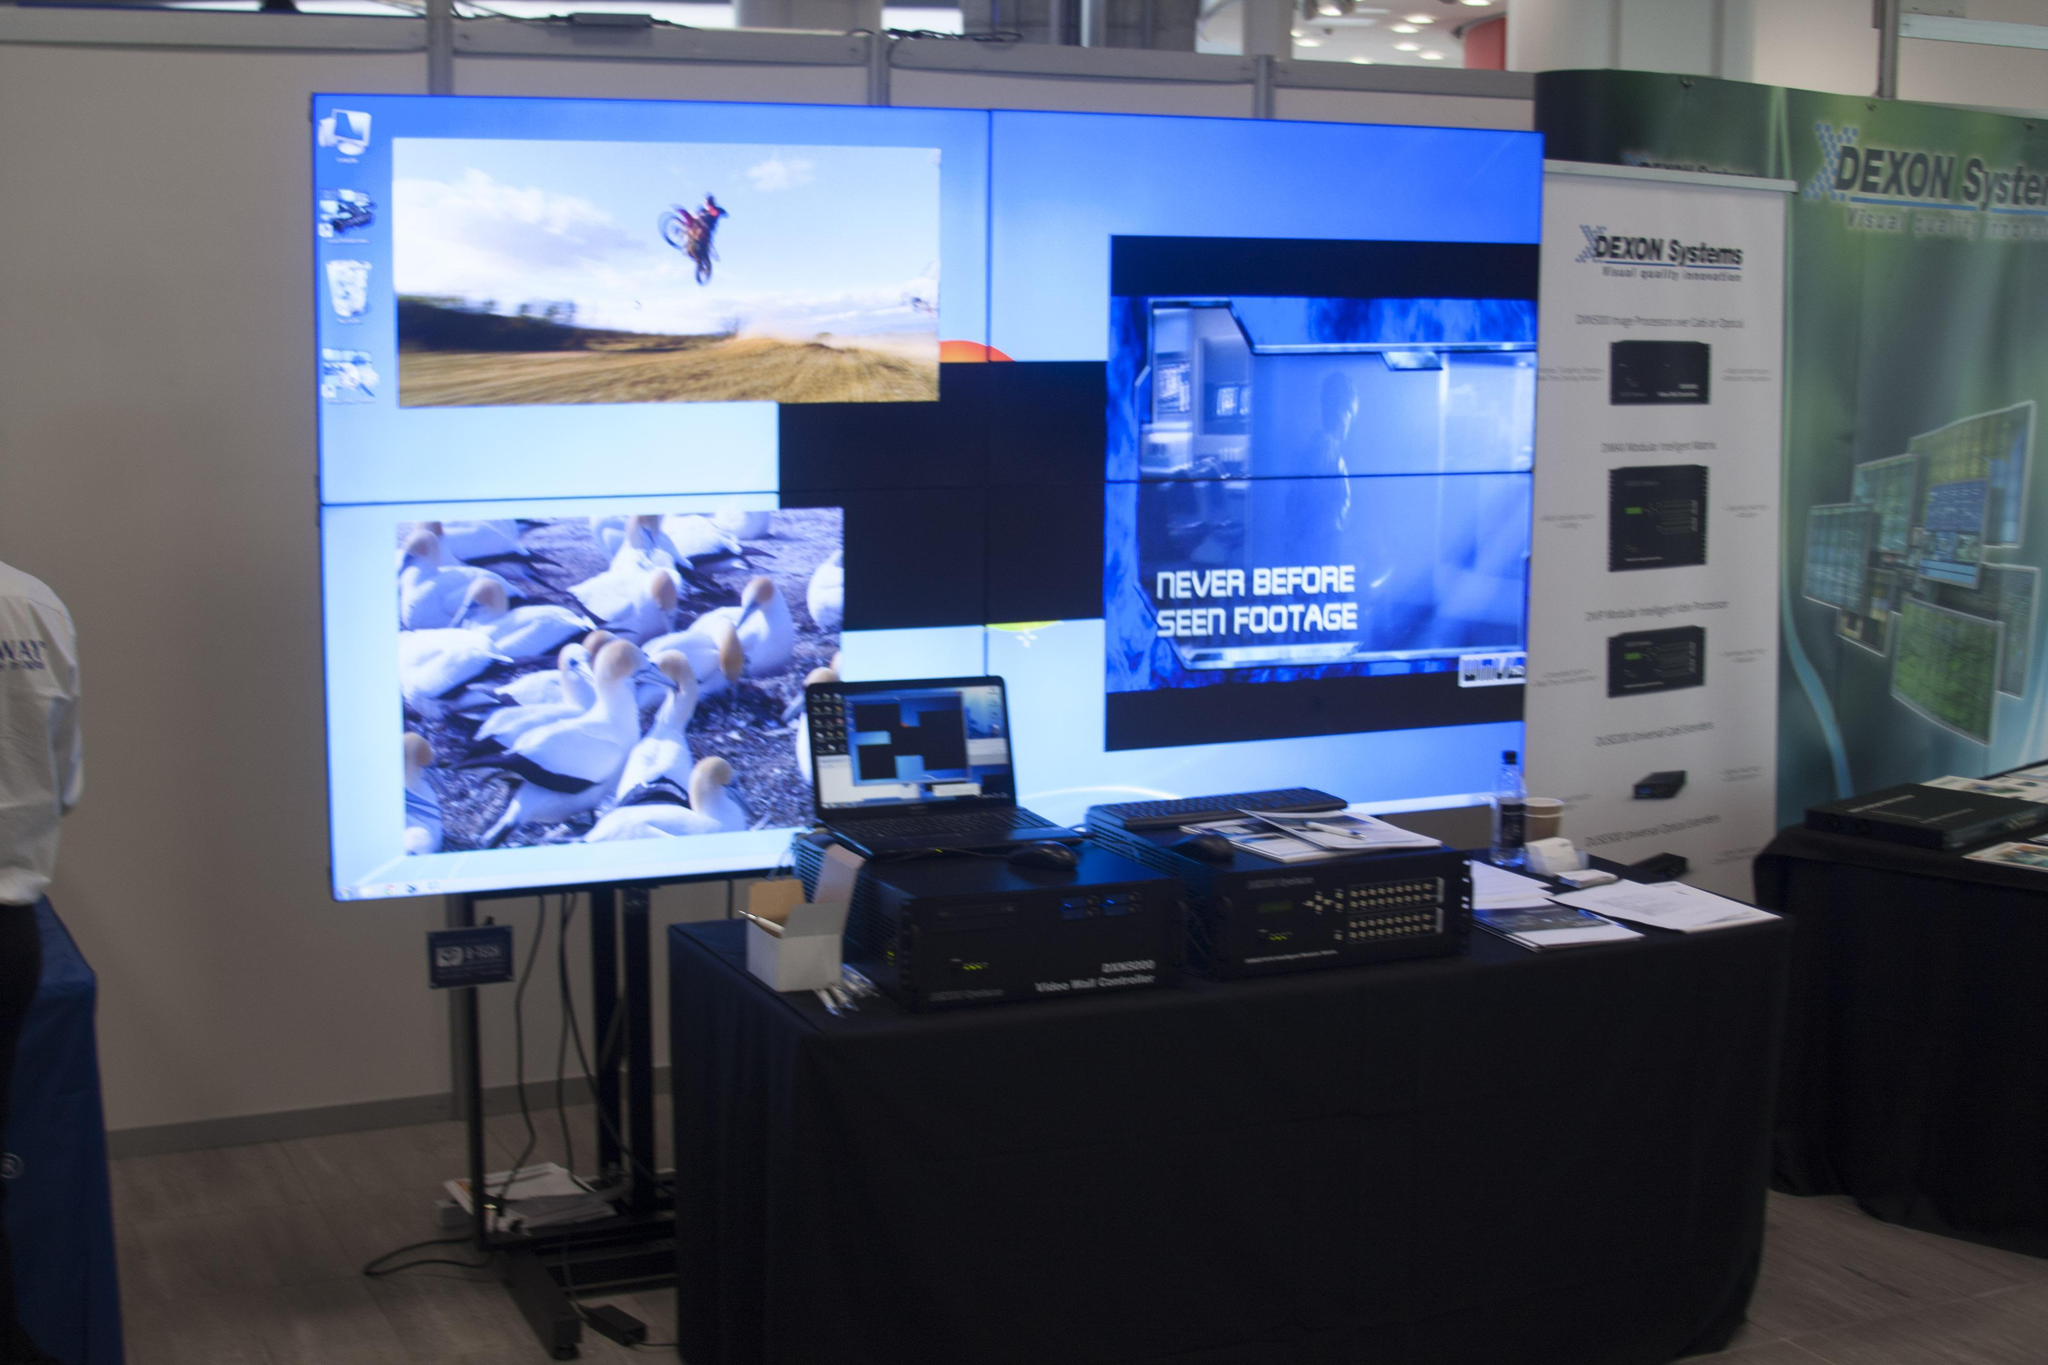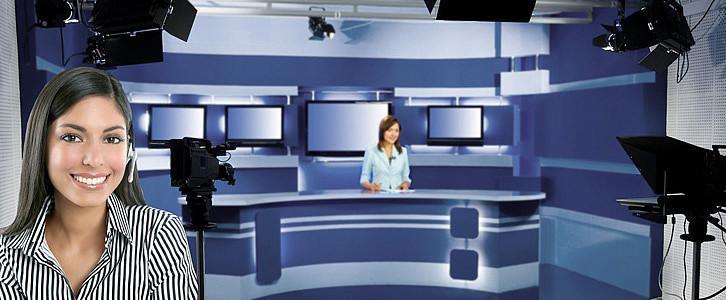The first image is the image on the left, the second image is the image on the right. Examine the images to the left and right. Is the description "The right image shows a seated person in the center, facing cameras." accurate? Answer yes or no. Yes. 